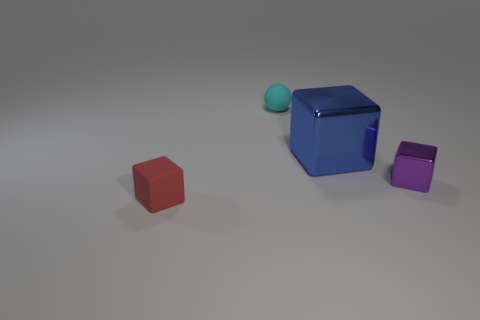Add 3 red rubber blocks. How many objects exist? 7 Subtract all balls. How many objects are left? 3 Subtract 0 gray balls. How many objects are left? 4 Subtract all red matte cubes. Subtract all small cubes. How many objects are left? 1 Add 1 small cubes. How many small cubes are left? 3 Add 2 tiny cyan matte cubes. How many tiny cyan matte cubes exist? 2 